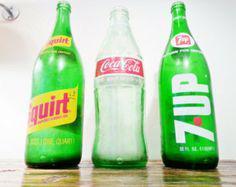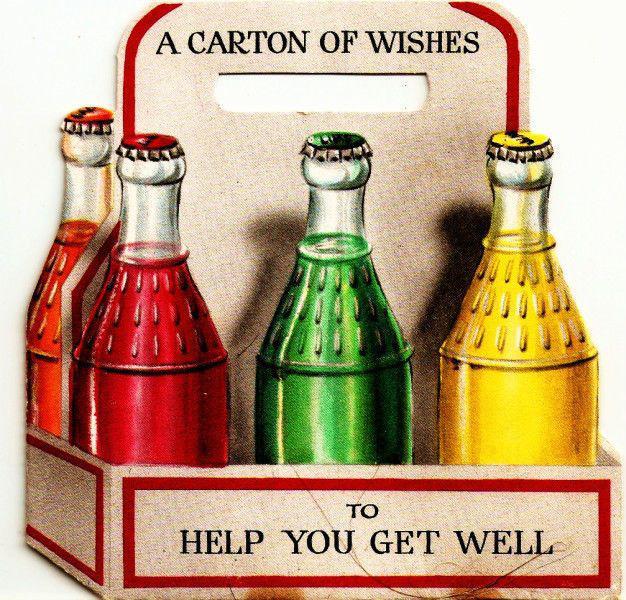The first image is the image on the left, the second image is the image on the right. For the images shown, is this caption "There are at least 3 green soda bottles within the rows of bottles." true? Answer yes or no. Yes. The first image is the image on the left, the second image is the image on the right. Given the left and right images, does the statement "All bottles have labels on them, and no bottles are in boxes." hold true? Answer yes or no. No. 